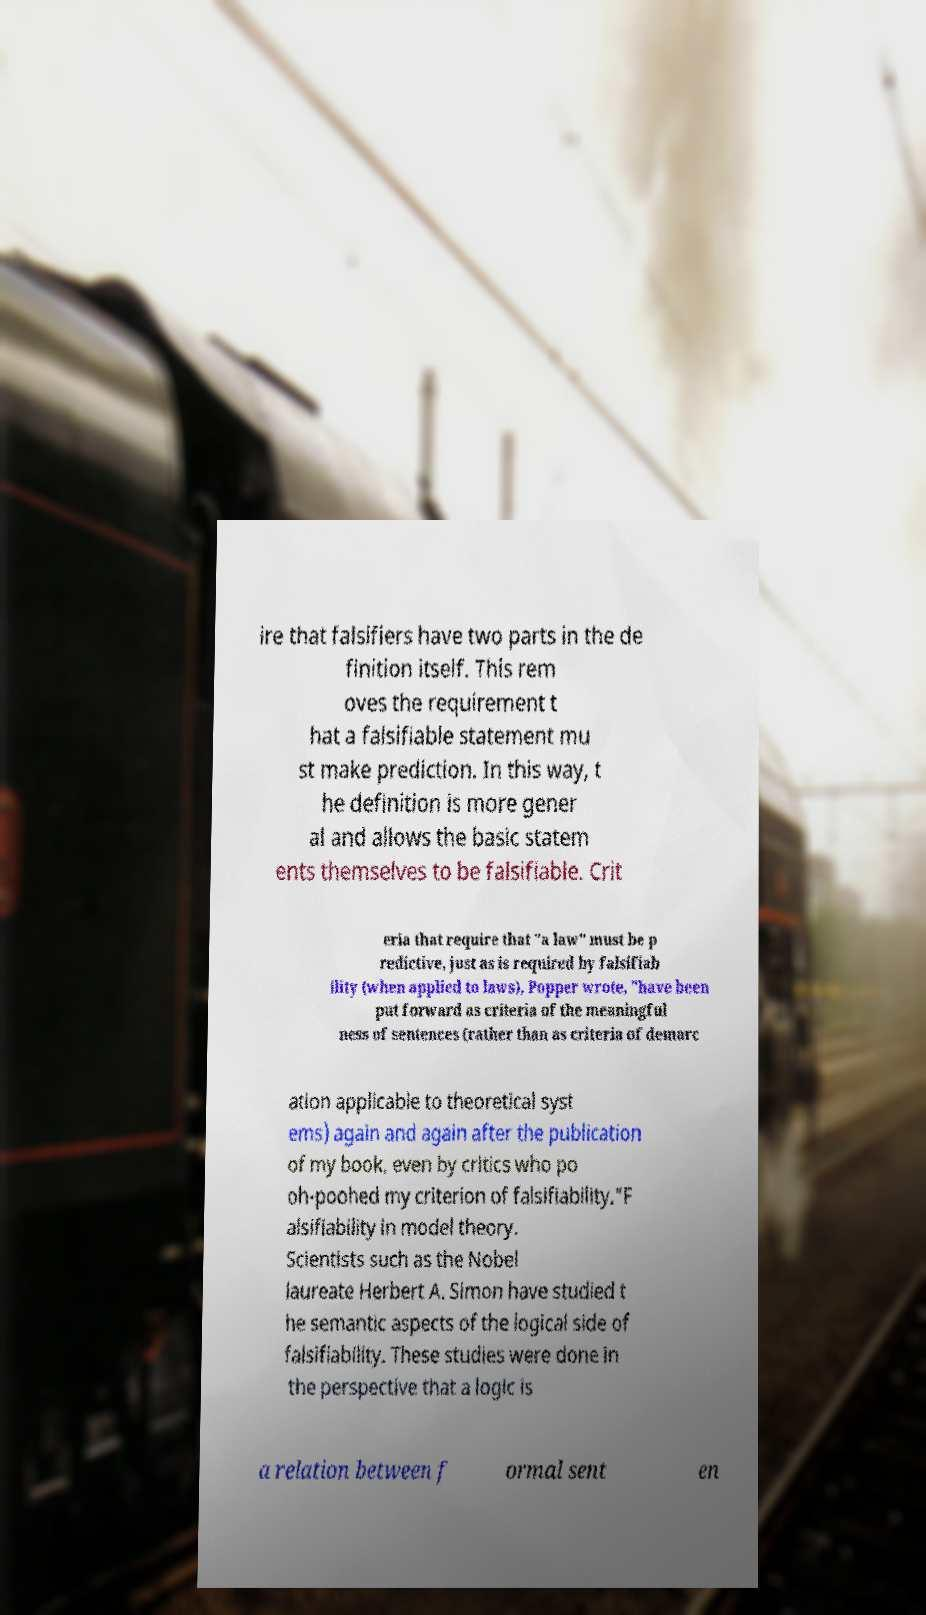Could you extract and type out the text from this image? ire that falsifiers have two parts in the de finition itself. This rem oves the requirement t hat a falsifiable statement mu st make prediction. In this way, t he definition is more gener al and allows the basic statem ents themselves to be falsifiable. Crit eria that require that "a law" must be p redictive, just as is required by falsifiab ility (when applied to laws), Popper wrote, "have been put forward as criteria of the meaningful ness of sentences (rather than as criteria of demarc ation applicable to theoretical syst ems) again and again after the publication of my book, even by critics who po oh-poohed my criterion of falsifiability."F alsifiability in model theory. Scientists such as the Nobel laureate Herbert A. Simon have studied t he semantic aspects of the logical side of falsifiability. These studies were done in the perspective that a logic is a relation between f ormal sent en 